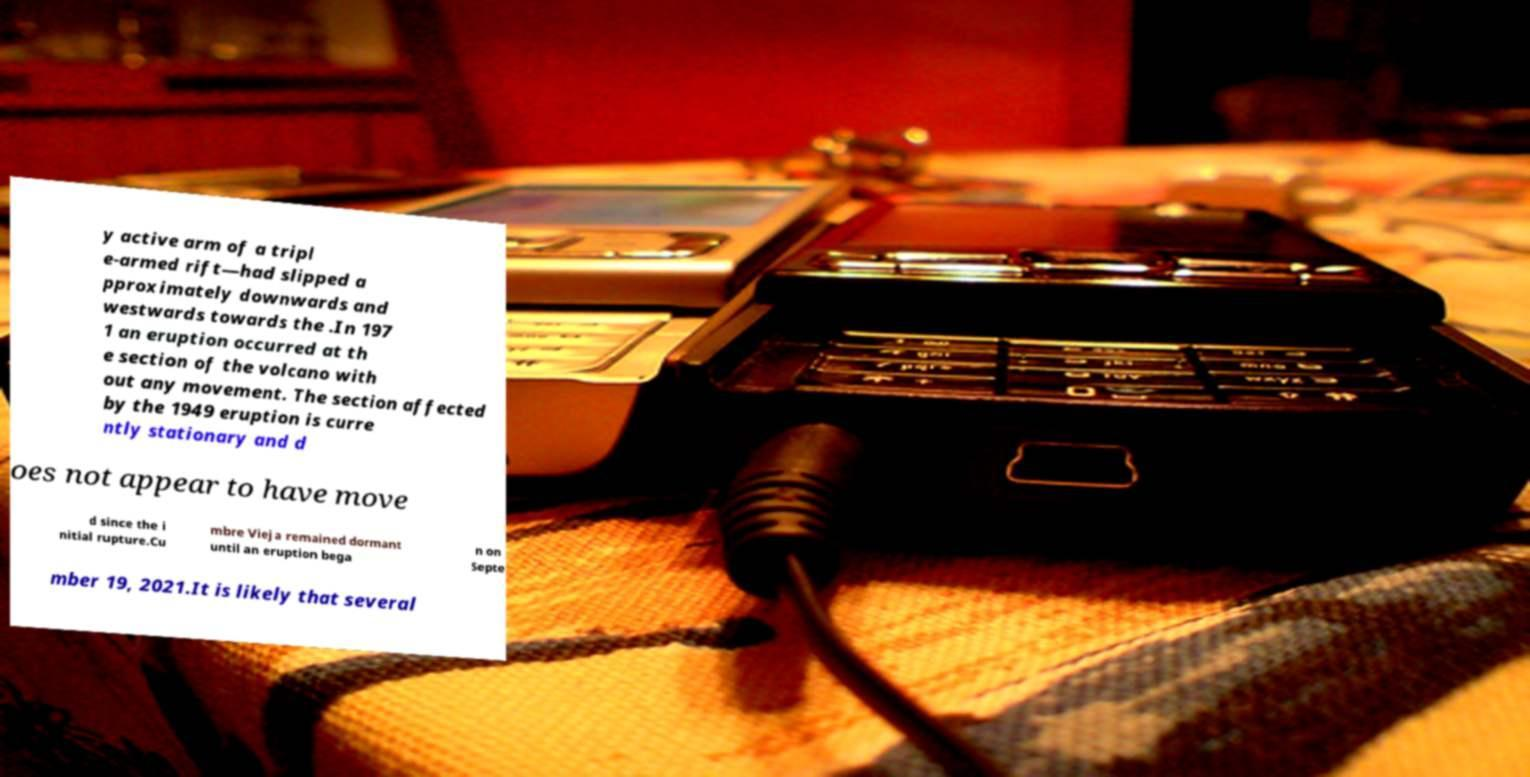Could you extract and type out the text from this image? y active arm of a tripl e-armed rift—had slipped a pproximately downwards and westwards towards the .In 197 1 an eruption occurred at th e section of the volcano with out any movement. The section affected by the 1949 eruption is curre ntly stationary and d oes not appear to have move d since the i nitial rupture.Cu mbre Vieja remained dormant until an eruption bega n on Septe mber 19, 2021.It is likely that several 